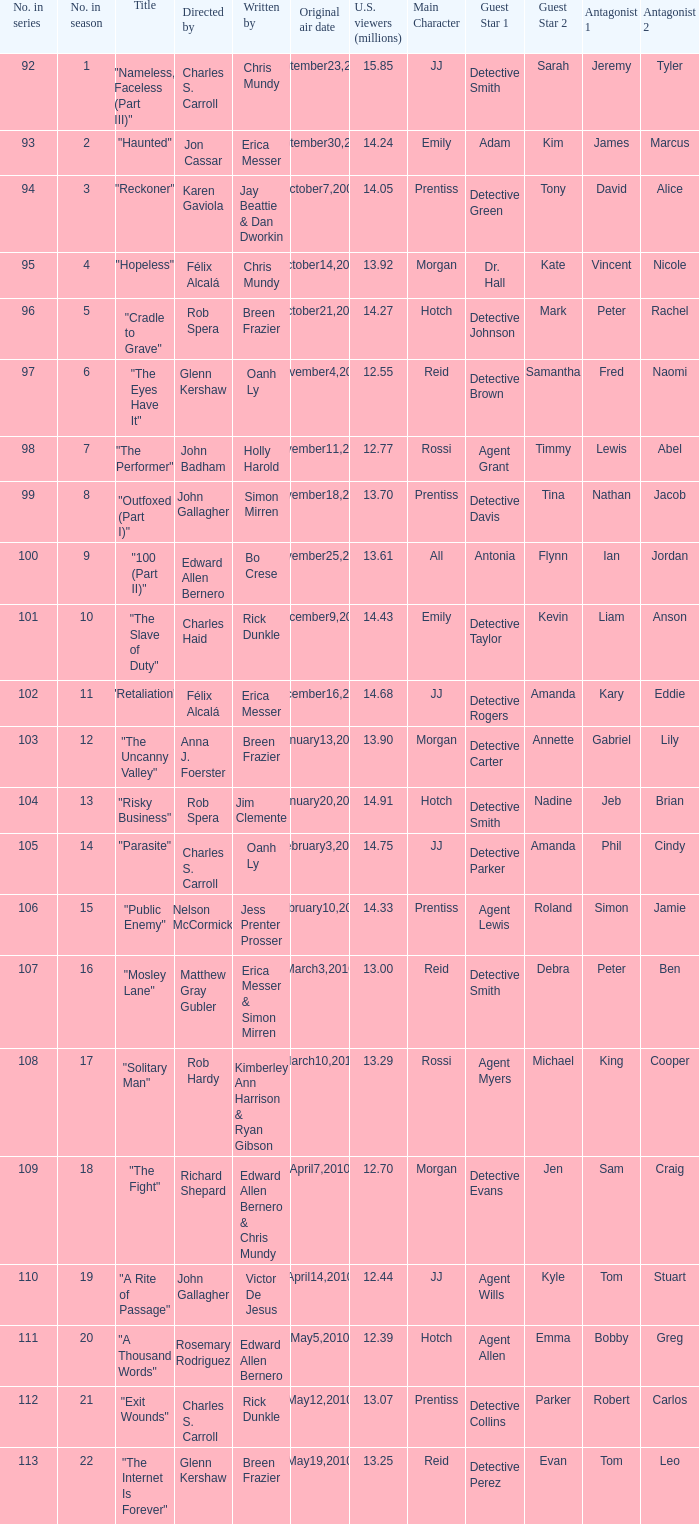Who wrote episode number 109 in the series? Edward Allen Bernero & Chris Mundy. 